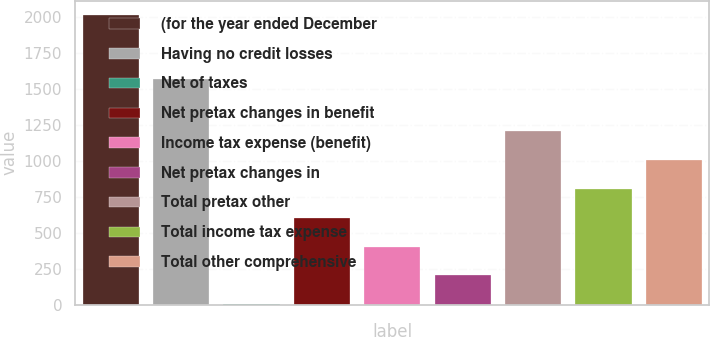<chart> <loc_0><loc_0><loc_500><loc_500><bar_chart><fcel>(for the year ended December<fcel>Having no credit losses<fcel>Net of taxes<fcel>Net pretax changes in benefit<fcel>Income tax expense (benefit)<fcel>Net pretax changes in<fcel>Total pretax other<fcel>Total income tax expense<fcel>Total other comprehensive<nl><fcel>2011<fcel>1570<fcel>2<fcel>604.7<fcel>403.8<fcel>202.9<fcel>1207.4<fcel>805.6<fcel>1006.5<nl></chart> 